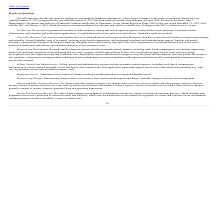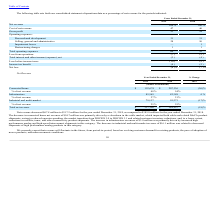According to Maxlinear's financial document, What are research and development activities? the design of new products, refinement of existing products and design of test methodologies to ensure compliance with required specifications.. The document states: "costs. Research and development activities include the design of new products, refinement of existing products and design of test methodologies to ens..." Also, can you calculate: What is the average Cost of net revenue, for the Years Ended December 31, 2019 to 2018? To answer this question, I need to perform calculations using the financial data. The calculation is: (47+46) / 2, which equals 46.5 (percentage). This is based on the information: "Cost of net revenue 47 46 Cost of net revenue 47 46..." The key data points involved are: 47. Also, can you calculate: What is the average Operating expenses: Selling, general and administrative, for the Years Ended December 31, 2019 to 2018? To answer this question, I need to perform calculations using the financial data. The calculation is: (28+26) / 2, which equals 27 (percentage). This is based on the information: "Selling, general and administrative 28 26 Selling, general and administrative 28 26..." The key data points involved are: 26, 28. Also, can you calculate: What is the average Loss from operations for the Years Ended December 31, 2019 to 2018? To answer this question, I need to perform calculations using the financial data. The calculation is: (7+5) / 2, which equals 6 (percentage). This is based on the information: "al Report on Form 10-K, but may be found in “Item 7. Management’s Discussion and Analysis of Financial Condition and Results of Operations” in our Annu December 31, 2018, filed with the SEC on Februar..." The key data points involved are: 5, 7. Also, What are the Research and development expense? personnel-related expenses, including stock-based compensation, new product engineering mask costs, prototype integrated circuit packaging and test costs, computer-aided design software license costs, intellectual property license costs, reference design development costs, development testing and evaluation costs, depreciation expense and allocated occupancy costs.. The document states: "lopment. Research and development expense includes personnel-related expenses, including stock-based compensation, new product engineering mask costs,..." Also, What are Restructuring Charges? consist of severance, lease and leasehold impairment charges, and other charges related to restructuring plans. The document states: "Restructuring Charges. Restructuring charges consist of severance, lease and leasehold impairment charges, and other charges related to restructuring ..." 